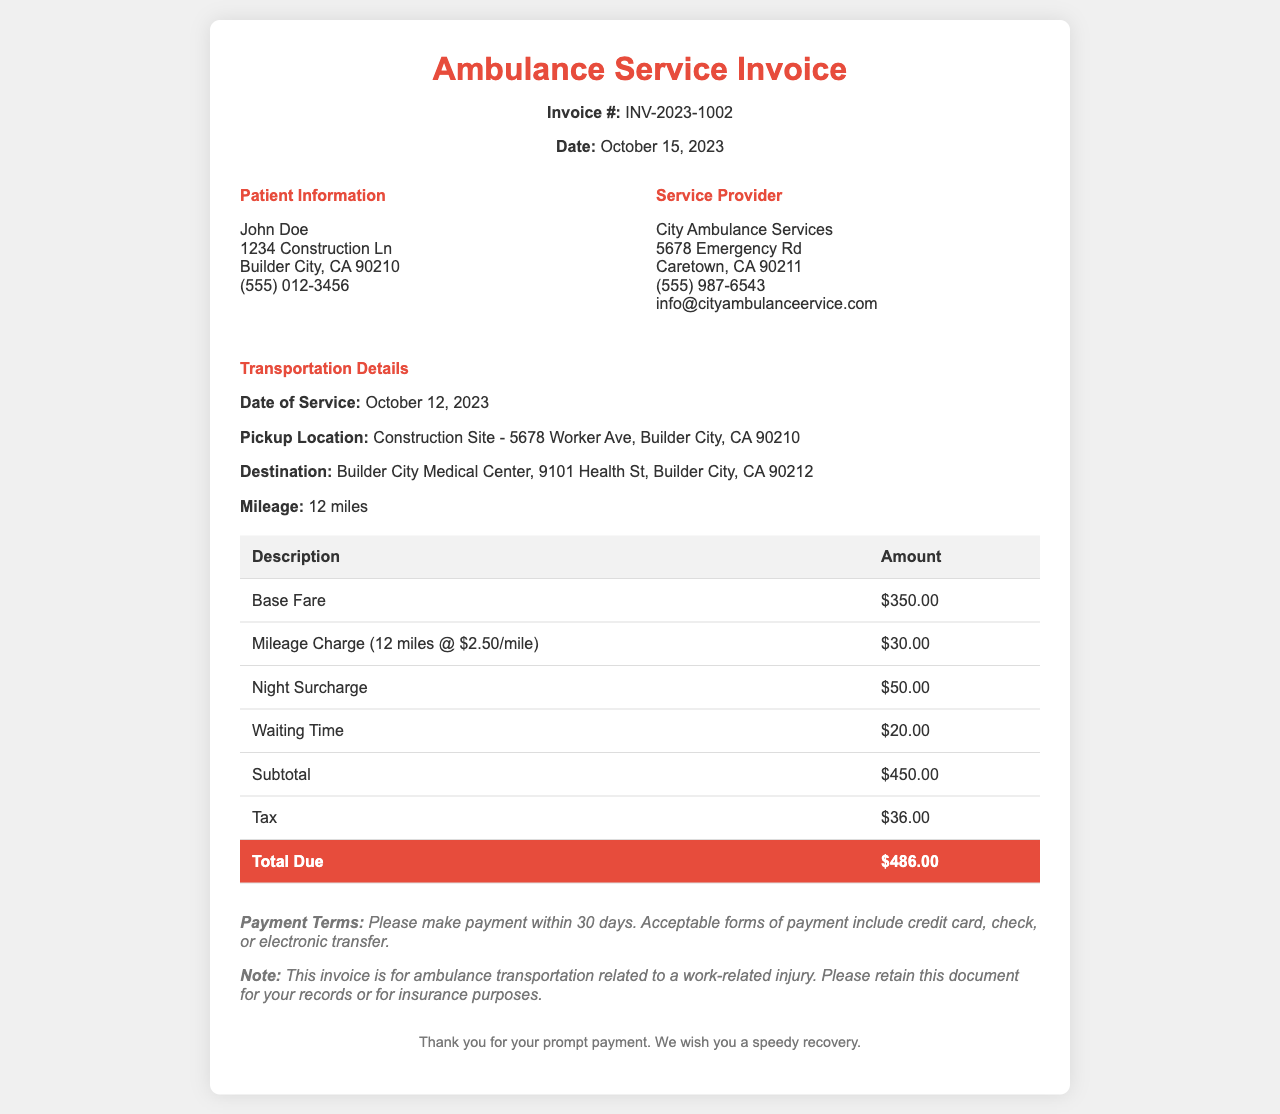What is the invoice number? The invoice number is stated clearly at the top of the document.
Answer: INV-2023-1002 What is the date of service? The date of service is mentioned in the transportation details section.
Answer: October 12, 2023 Who is the patient? The patient information section identifies the name of the patient.
Answer: John Doe What is the mileage charged? The mileage charge is specified in the transportation details.
Answer: 12 miles What is the total amount due? The total amount due is highlighted at the bottom of the cost table.
Answer: $486.00 How much is the base fare? The base fare amount is listed in the invoice table.
Answer: $350.00 What is the waiting time charge? The waiting time charge is provided in the breakdown of charges.
Answer: $20.00 What is the tax amount? The tax amount is detailed in the invoice under the subtotal.
Answer: $36.00 What should you do with this invoice for insurance purposes? The document specifies a note regarding the retention of the invoice.
Answer: Retain this document for your records or for insurance purposes 